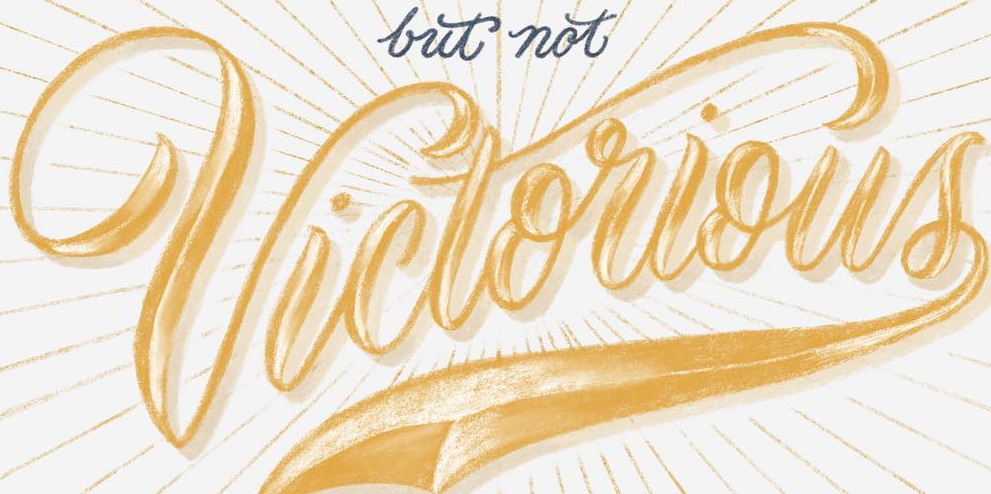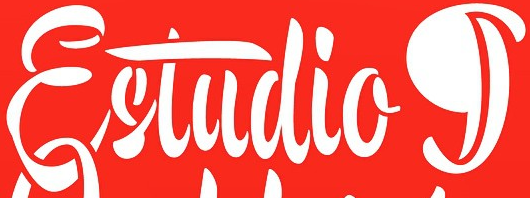What words are shown in these images in order, separated by a semicolon? Victorious; Estudiog 